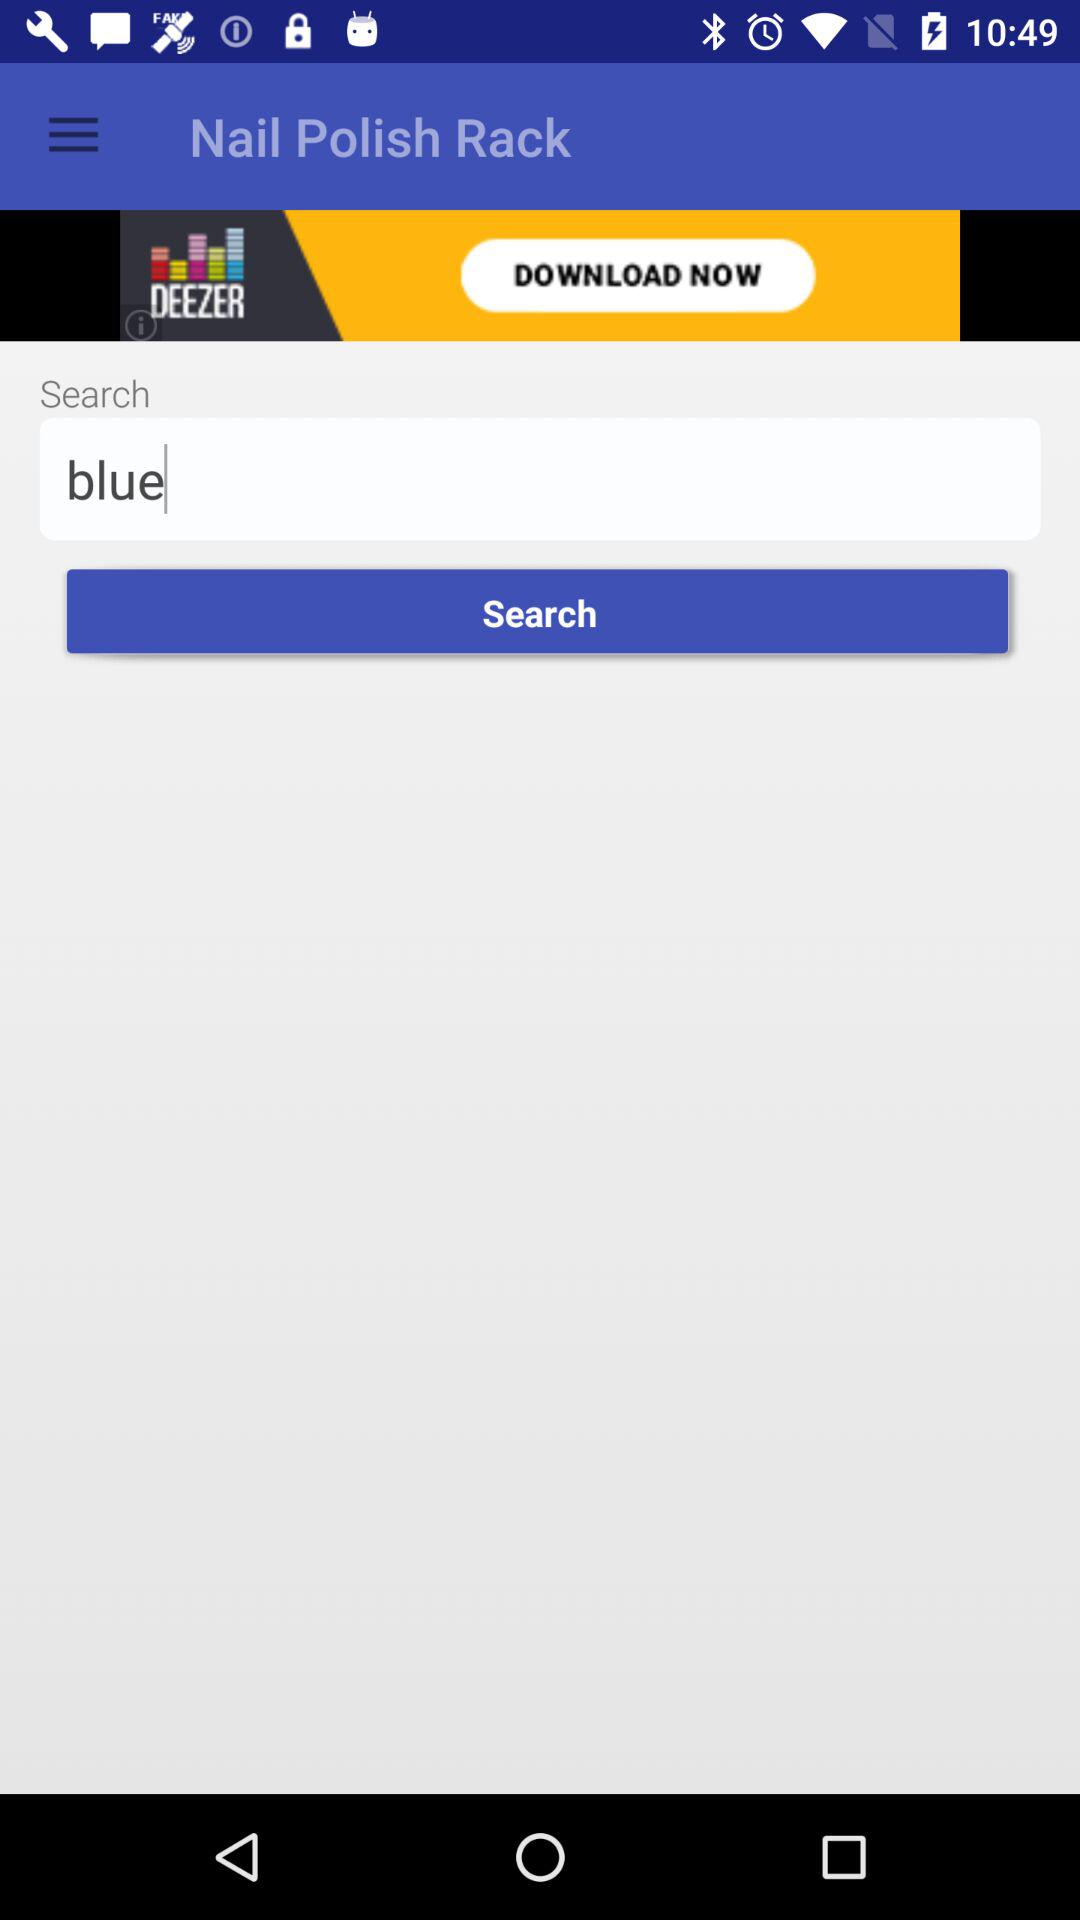What is the application name? The application name is "Nail Polish Rack". 